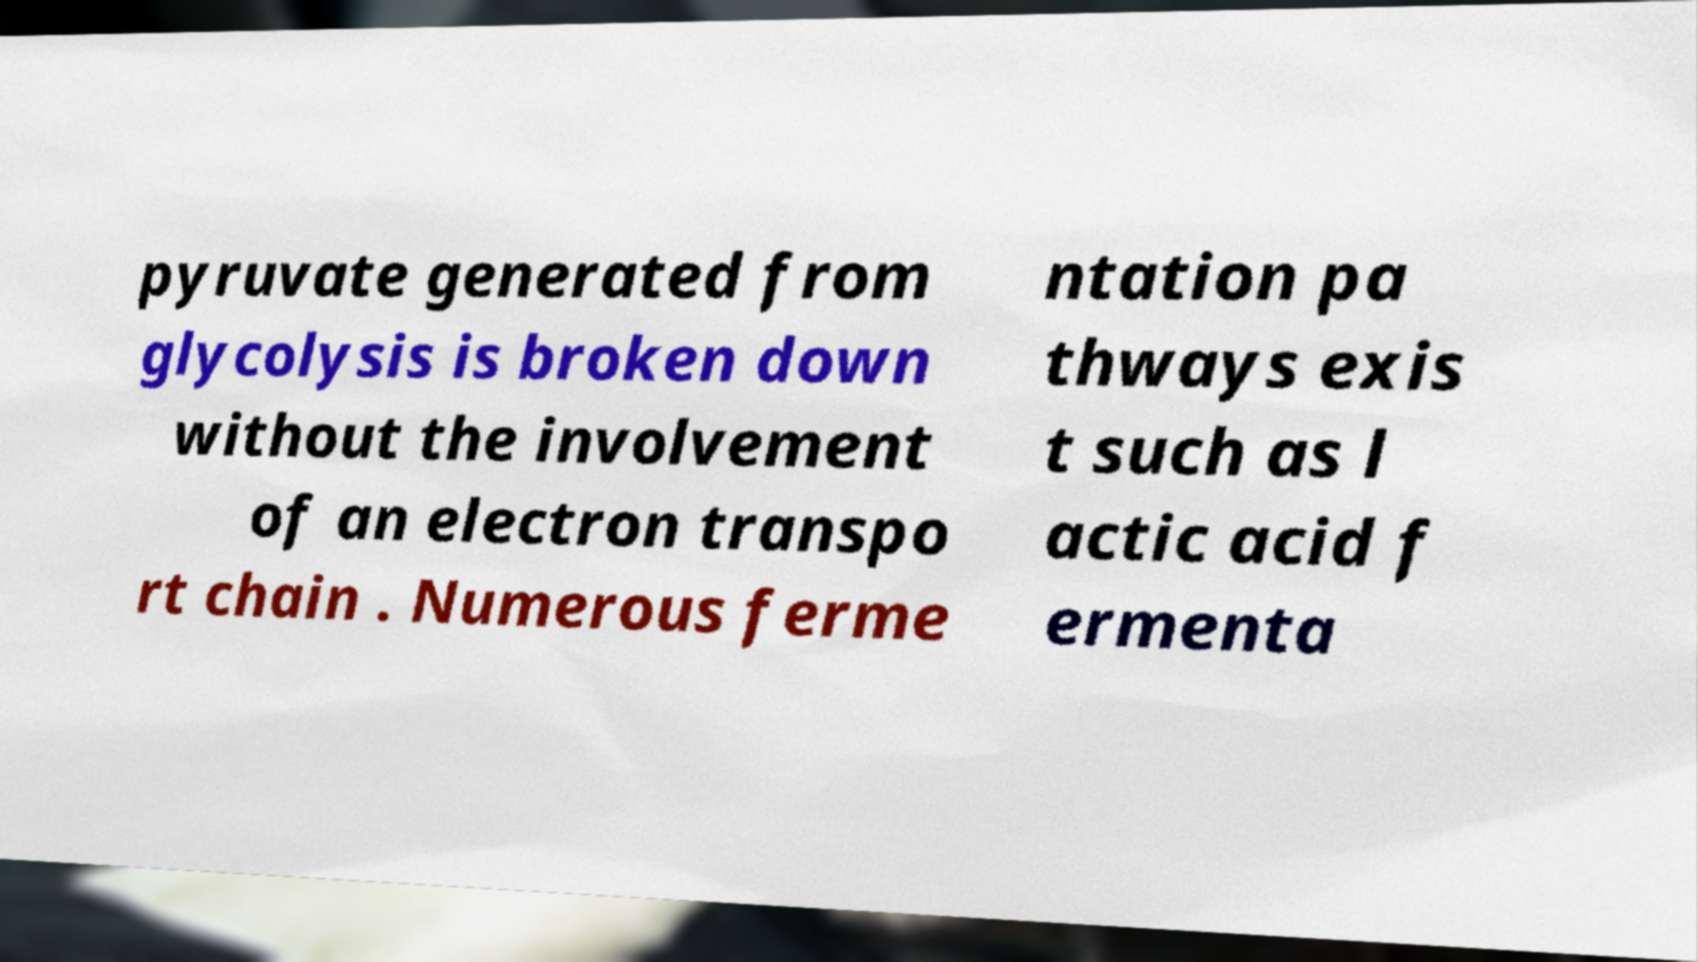Please read and relay the text visible in this image. What does it say? pyruvate generated from glycolysis is broken down without the involvement of an electron transpo rt chain . Numerous ferme ntation pa thways exis t such as l actic acid f ermenta 